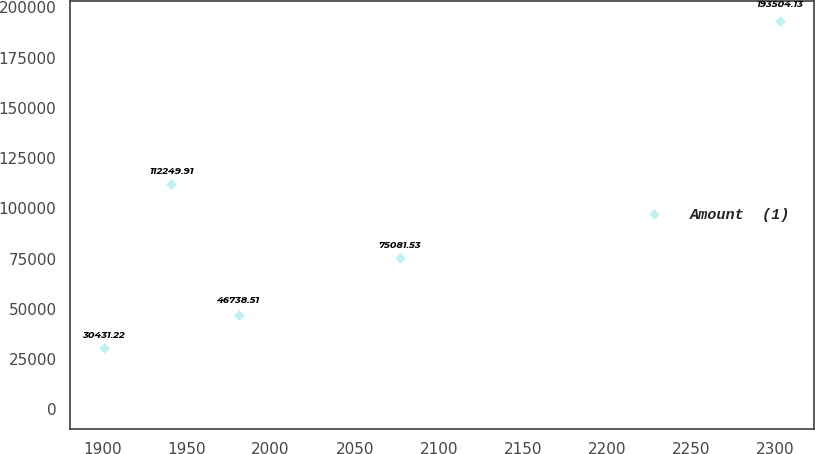Convert chart to OTSL. <chart><loc_0><loc_0><loc_500><loc_500><line_chart><ecel><fcel>Amount  (1)<nl><fcel>1900.71<fcel>30431.2<nl><fcel>1940.9<fcel>112250<nl><fcel>1981.09<fcel>46738.5<nl><fcel>2076.79<fcel>75081.5<nl><fcel>2302.58<fcel>193504<nl></chart> 